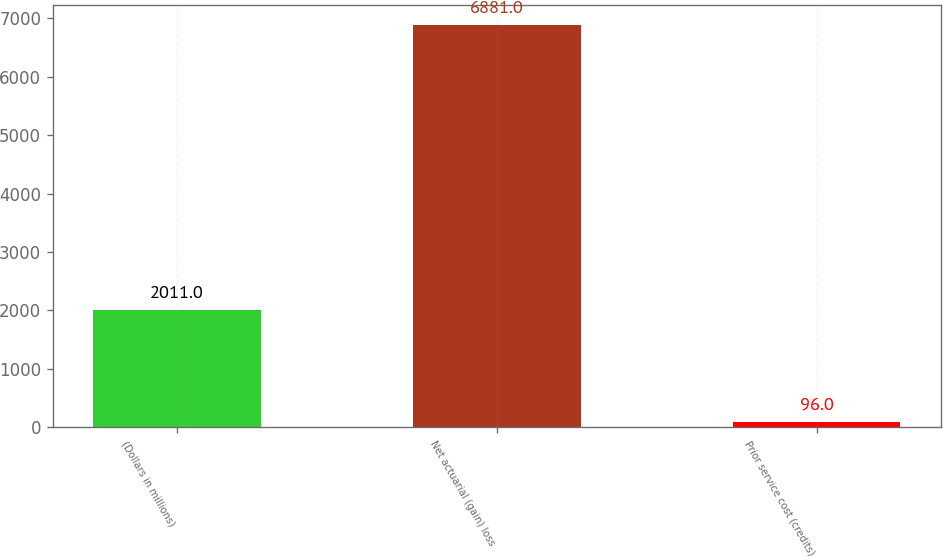Convert chart to OTSL. <chart><loc_0><loc_0><loc_500><loc_500><bar_chart><fcel>(Dollars in millions)<fcel>Net actuarial (gain) loss<fcel>Prior service cost (credits)<nl><fcel>2011<fcel>6881<fcel>96<nl></chart> 